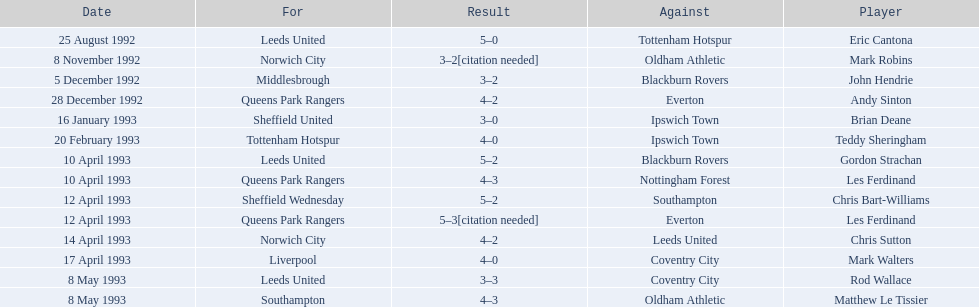Who are all the players? Eric Cantona, Mark Robins, John Hendrie, Andy Sinton, Brian Deane, Teddy Sheringham, Gordon Strachan, Les Ferdinand, Chris Bart-Williams, Les Ferdinand, Chris Sutton, Mark Walters, Rod Wallace, Matthew Le Tissier. What were their results? 5–0, 3–2[citation needed], 3–2, 4–2, 3–0, 4–0, 5–2, 4–3, 5–2, 5–3[citation needed], 4–2, 4–0, 3–3, 4–3. Which player tied with mark robins? John Hendrie. 